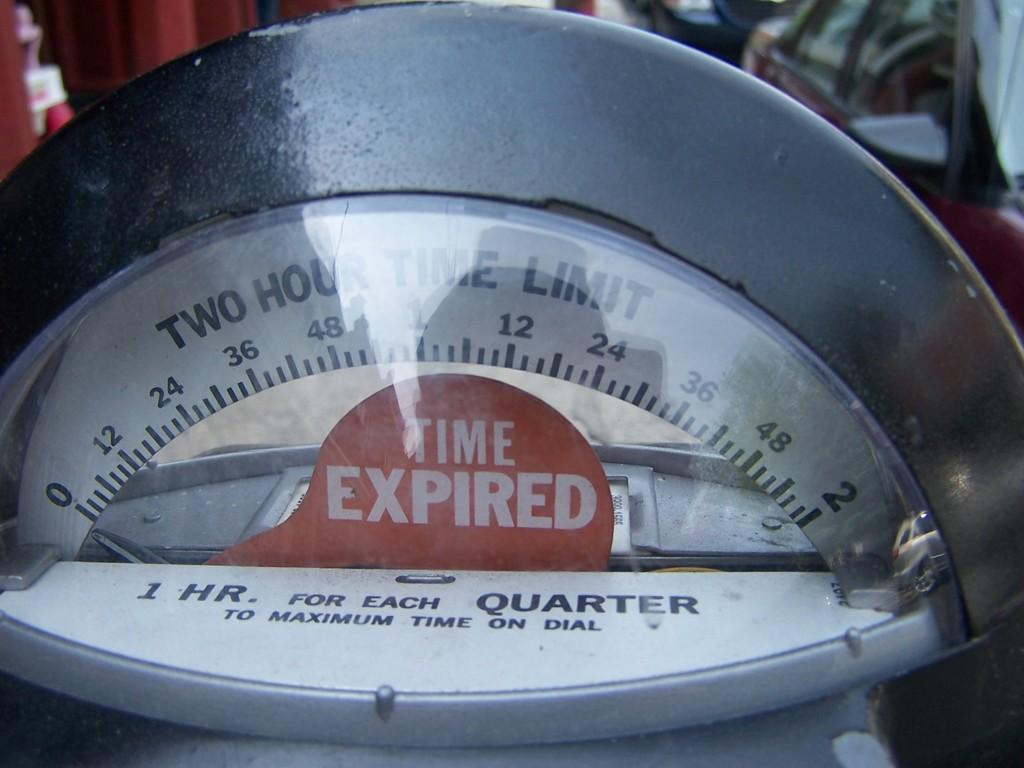<image>
Describe the image concisely. A parking meter is a two hour time limit is showing that the time has expired. 